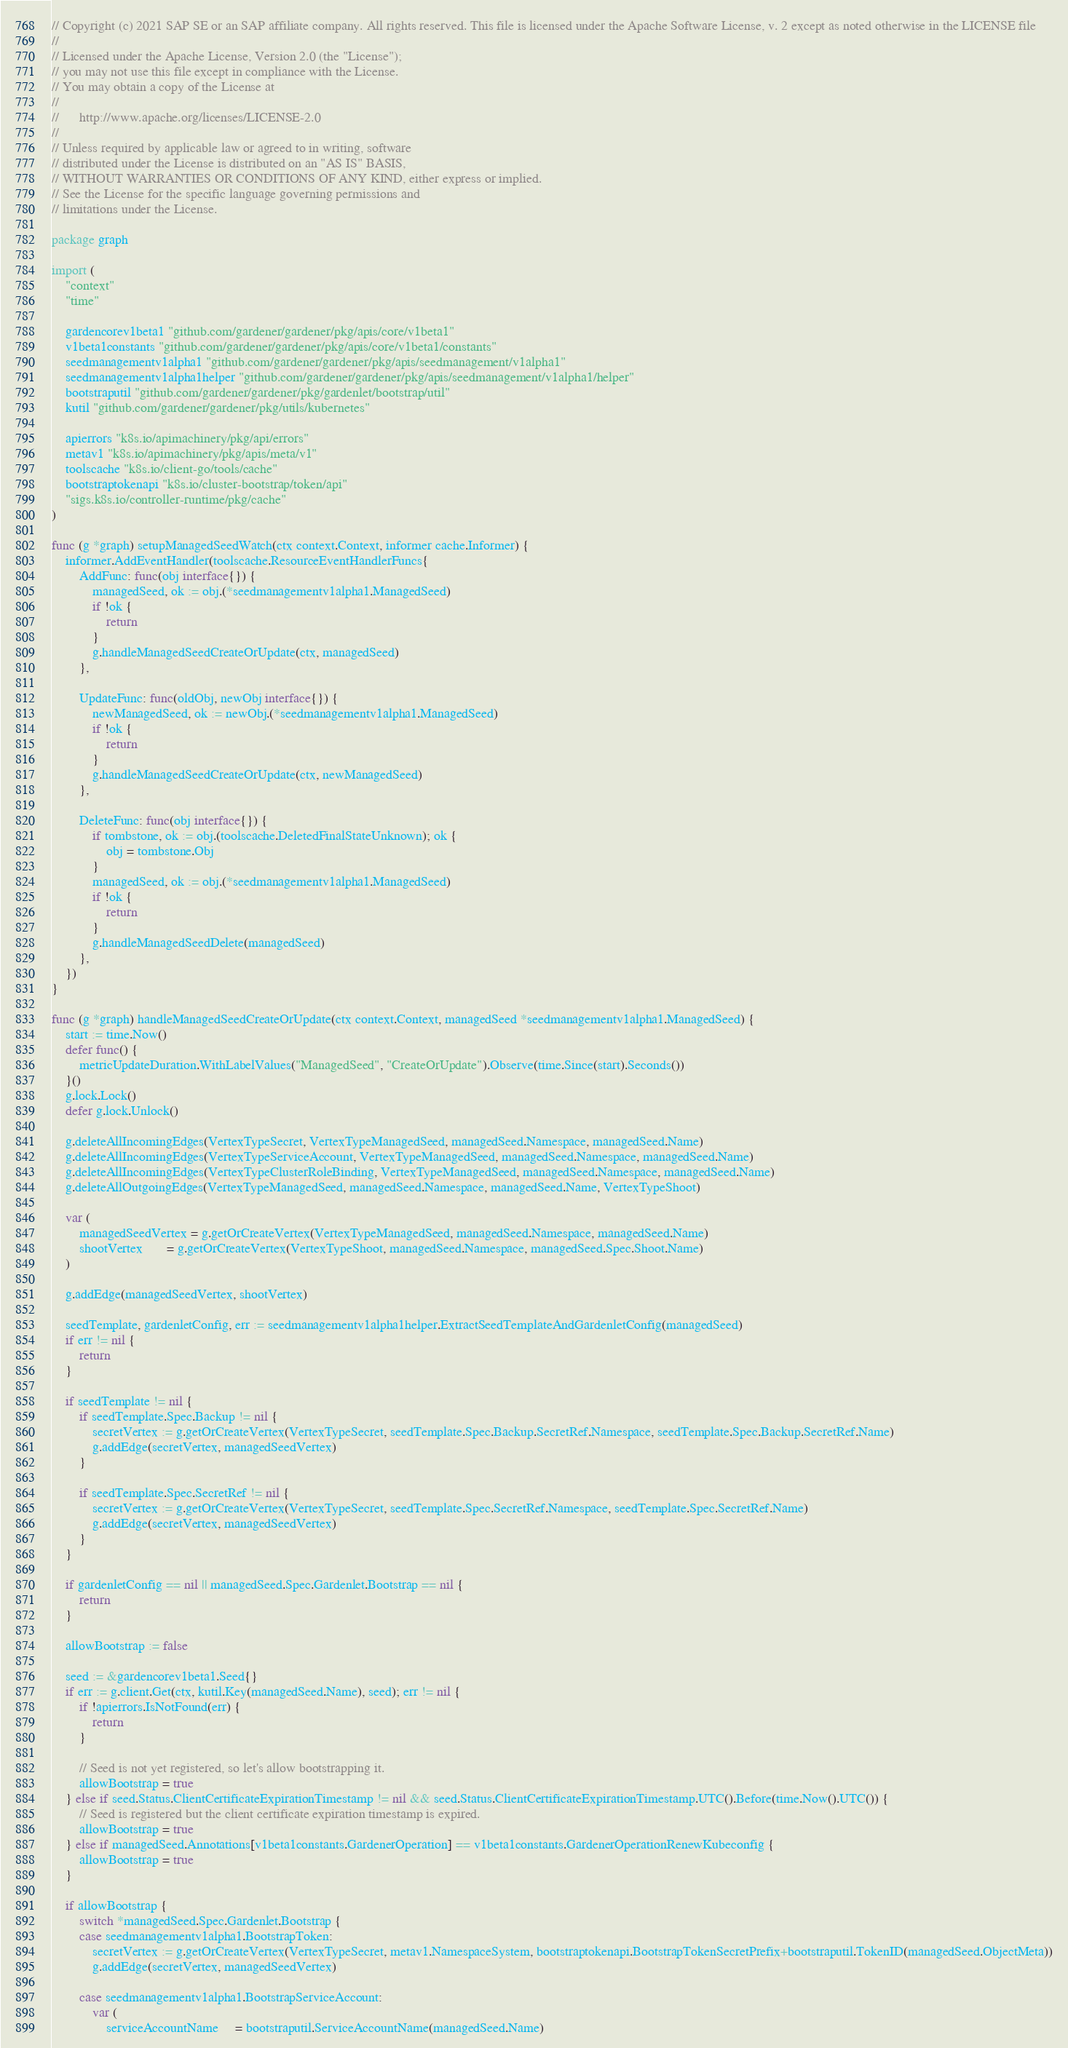Convert code to text. <code><loc_0><loc_0><loc_500><loc_500><_Go_>// Copyright (c) 2021 SAP SE or an SAP affiliate company. All rights reserved. This file is licensed under the Apache Software License, v. 2 except as noted otherwise in the LICENSE file
//
// Licensed under the Apache License, Version 2.0 (the "License");
// you may not use this file except in compliance with the License.
// You may obtain a copy of the License at
//
//      http://www.apache.org/licenses/LICENSE-2.0
//
// Unless required by applicable law or agreed to in writing, software
// distributed under the License is distributed on an "AS IS" BASIS,
// WITHOUT WARRANTIES OR CONDITIONS OF ANY KIND, either express or implied.
// See the License for the specific language governing permissions and
// limitations under the License.

package graph

import (
	"context"
	"time"

	gardencorev1beta1 "github.com/gardener/gardener/pkg/apis/core/v1beta1"
	v1beta1constants "github.com/gardener/gardener/pkg/apis/core/v1beta1/constants"
	seedmanagementv1alpha1 "github.com/gardener/gardener/pkg/apis/seedmanagement/v1alpha1"
	seedmanagementv1alpha1helper "github.com/gardener/gardener/pkg/apis/seedmanagement/v1alpha1/helper"
	bootstraputil "github.com/gardener/gardener/pkg/gardenlet/bootstrap/util"
	kutil "github.com/gardener/gardener/pkg/utils/kubernetes"

	apierrors "k8s.io/apimachinery/pkg/api/errors"
	metav1 "k8s.io/apimachinery/pkg/apis/meta/v1"
	toolscache "k8s.io/client-go/tools/cache"
	bootstraptokenapi "k8s.io/cluster-bootstrap/token/api"
	"sigs.k8s.io/controller-runtime/pkg/cache"
)

func (g *graph) setupManagedSeedWatch(ctx context.Context, informer cache.Informer) {
	informer.AddEventHandler(toolscache.ResourceEventHandlerFuncs{
		AddFunc: func(obj interface{}) {
			managedSeed, ok := obj.(*seedmanagementv1alpha1.ManagedSeed)
			if !ok {
				return
			}
			g.handleManagedSeedCreateOrUpdate(ctx, managedSeed)
		},

		UpdateFunc: func(oldObj, newObj interface{}) {
			newManagedSeed, ok := newObj.(*seedmanagementv1alpha1.ManagedSeed)
			if !ok {
				return
			}
			g.handleManagedSeedCreateOrUpdate(ctx, newManagedSeed)
		},

		DeleteFunc: func(obj interface{}) {
			if tombstone, ok := obj.(toolscache.DeletedFinalStateUnknown); ok {
				obj = tombstone.Obj
			}
			managedSeed, ok := obj.(*seedmanagementv1alpha1.ManagedSeed)
			if !ok {
				return
			}
			g.handleManagedSeedDelete(managedSeed)
		},
	})
}

func (g *graph) handleManagedSeedCreateOrUpdate(ctx context.Context, managedSeed *seedmanagementv1alpha1.ManagedSeed) {
	start := time.Now()
	defer func() {
		metricUpdateDuration.WithLabelValues("ManagedSeed", "CreateOrUpdate").Observe(time.Since(start).Seconds())
	}()
	g.lock.Lock()
	defer g.lock.Unlock()

	g.deleteAllIncomingEdges(VertexTypeSecret, VertexTypeManagedSeed, managedSeed.Namespace, managedSeed.Name)
	g.deleteAllIncomingEdges(VertexTypeServiceAccount, VertexTypeManagedSeed, managedSeed.Namespace, managedSeed.Name)
	g.deleteAllIncomingEdges(VertexTypeClusterRoleBinding, VertexTypeManagedSeed, managedSeed.Namespace, managedSeed.Name)
	g.deleteAllOutgoingEdges(VertexTypeManagedSeed, managedSeed.Namespace, managedSeed.Name, VertexTypeShoot)

	var (
		managedSeedVertex = g.getOrCreateVertex(VertexTypeManagedSeed, managedSeed.Namespace, managedSeed.Name)
		shootVertex       = g.getOrCreateVertex(VertexTypeShoot, managedSeed.Namespace, managedSeed.Spec.Shoot.Name)
	)

	g.addEdge(managedSeedVertex, shootVertex)

	seedTemplate, gardenletConfig, err := seedmanagementv1alpha1helper.ExtractSeedTemplateAndGardenletConfig(managedSeed)
	if err != nil {
		return
	}

	if seedTemplate != nil {
		if seedTemplate.Spec.Backup != nil {
			secretVertex := g.getOrCreateVertex(VertexTypeSecret, seedTemplate.Spec.Backup.SecretRef.Namespace, seedTemplate.Spec.Backup.SecretRef.Name)
			g.addEdge(secretVertex, managedSeedVertex)
		}

		if seedTemplate.Spec.SecretRef != nil {
			secretVertex := g.getOrCreateVertex(VertexTypeSecret, seedTemplate.Spec.SecretRef.Namespace, seedTemplate.Spec.SecretRef.Name)
			g.addEdge(secretVertex, managedSeedVertex)
		}
	}

	if gardenletConfig == nil || managedSeed.Spec.Gardenlet.Bootstrap == nil {
		return
	}

	allowBootstrap := false

	seed := &gardencorev1beta1.Seed{}
	if err := g.client.Get(ctx, kutil.Key(managedSeed.Name), seed); err != nil {
		if !apierrors.IsNotFound(err) {
			return
		}

		// Seed is not yet registered, so let's allow bootstrapping it.
		allowBootstrap = true
	} else if seed.Status.ClientCertificateExpirationTimestamp != nil && seed.Status.ClientCertificateExpirationTimestamp.UTC().Before(time.Now().UTC()) {
		// Seed is registered but the client certificate expiration timestamp is expired.
		allowBootstrap = true
	} else if managedSeed.Annotations[v1beta1constants.GardenerOperation] == v1beta1constants.GardenerOperationRenewKubeconfig {
		allowBootstrap = true
	}

	if allowBootstrap {
		switch *managedSeed.Spec.Gardenlet.Bootstrap {
		case seedmanagementv1alpha1.BootstrapToken:
			secretVertex := g.getOrCreateVertex(VertexTypeSecret, metav1.NamespaceSystem, bootstraptokenapi.BootstrapTokenSecretPrefix+bootstraputil.TokenID(managedSeed.ObjectMeta))
			g.addEdge(secretVertex, managedSeedVertex)

		case seedmanagementv1alpha1.BootstrapServiceAccount:
			var (
				serviceAccountName     = bootstraputil.ServiceAccountName(managedSeed.Name)</code> 